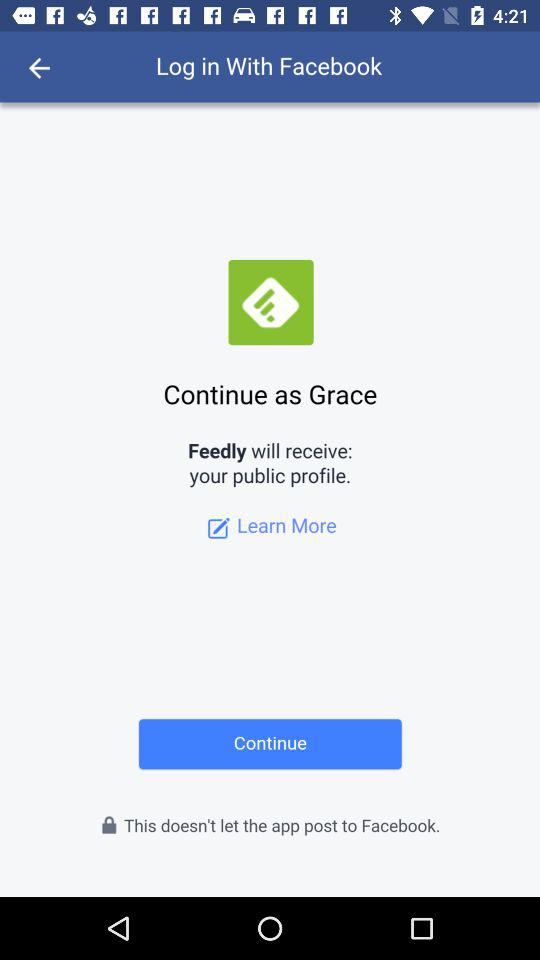What application is asking for permission? The application which asks for permission is "Feedly". 